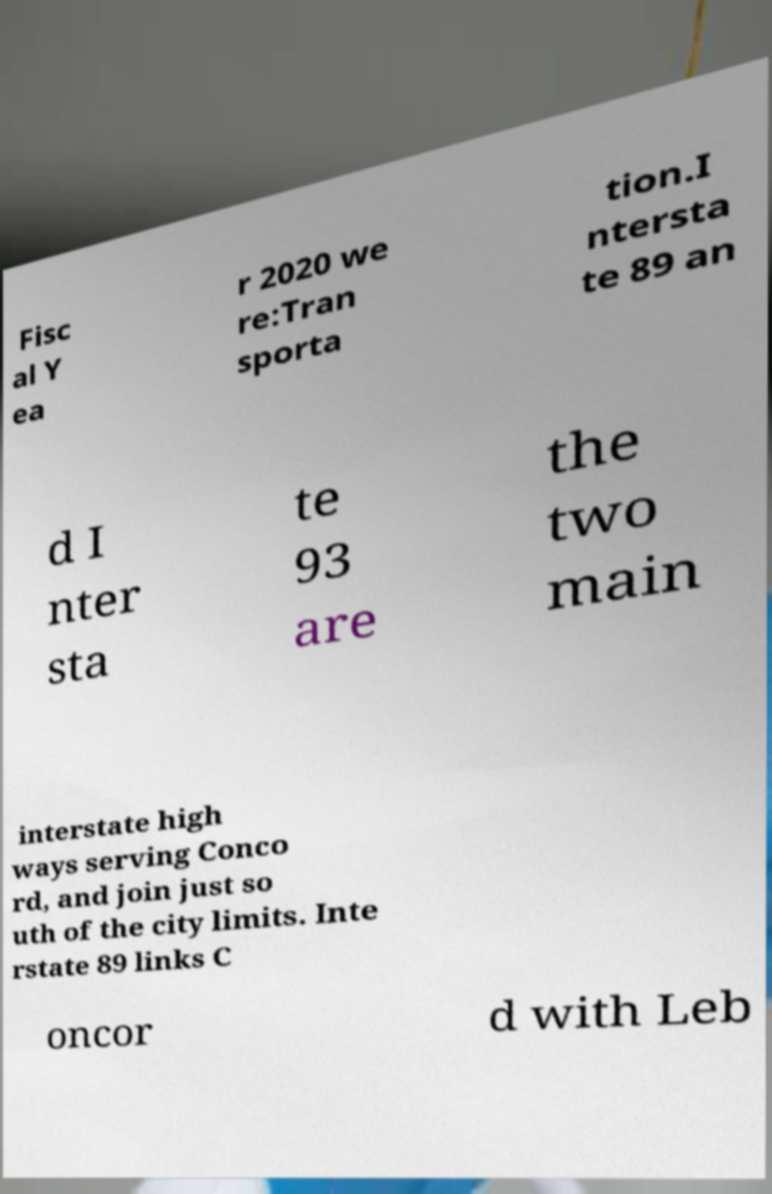There's text embedded in this image that I need extracted. Can you transcribe it verbatim? Fisc al Y ea r 2020 we re:Tran sporta tion.I ntersta te 89 an d I nter sta te 93 are the two main interstate high ways serving Conco rd, and join just so uth of the city limits. Inte rstate 89 links C oncor d with Leb 